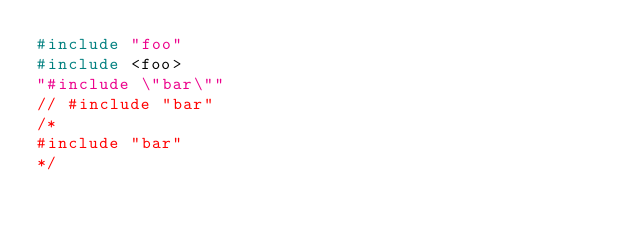<code> <loc_0><loc_0><loc_500><loc_500><_C++_>#include "foo"
#include <foo>
"#include \"bar\""
// #include "bar"
/*
#include "bar"
*/
</code> 